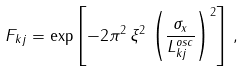<formula> <loc_0><loc_0><loc_500><loc_500>F _ { k j } = \exp \left [ - 2 \pi ^ { 2 } \, \xi ^ { 2 } \, \left ( \frac { \sigma _ { x } } { L _ { k j } ^ { o s c } } \right ) ^ { 2 } \right ] \, ,</formula> 